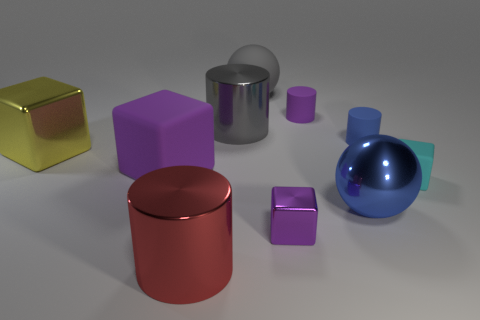There is a matte block that is the same color as the small metal cube; what is its size?
Make the answer very short. Large. There is a big gray thing in front of the small purple rubber cylinder; what material is it?
Provide a succinct answer. Metal. The small object in front of the cyan matte block to the right of the large purple matte object is what shape?
Give a very brief answer. Cube. There is a big yellow shiny thing; is it the same shape as the big purple matte thing behind the small cyan rubber cube?
Offer a terse response. Yes. There is a blue metallic object to the right of the gray metallic cylinder; what number of small things are in front of it?
Your answer should be compact. 1. There is another purple object that is the same shape as the large purple matte thing; what is it made of?
Give a very brief answer. Metal. How many purple objects are large balls or small metal things?
Your answer should be compact. 1. Is there any other thing that is the same color as the large matte ball?
Provide a short and direct response. Yes. The large matte object that is behind the metal cylinder that is to the right of the large red metal cylinder is what color?
Make the answer very short. Gray. Are there fewer large cylinders that are to the right of the big rubber sphere than yellow blocks that are to the left of the red cylinder?
Make the answer very short. Yes. 